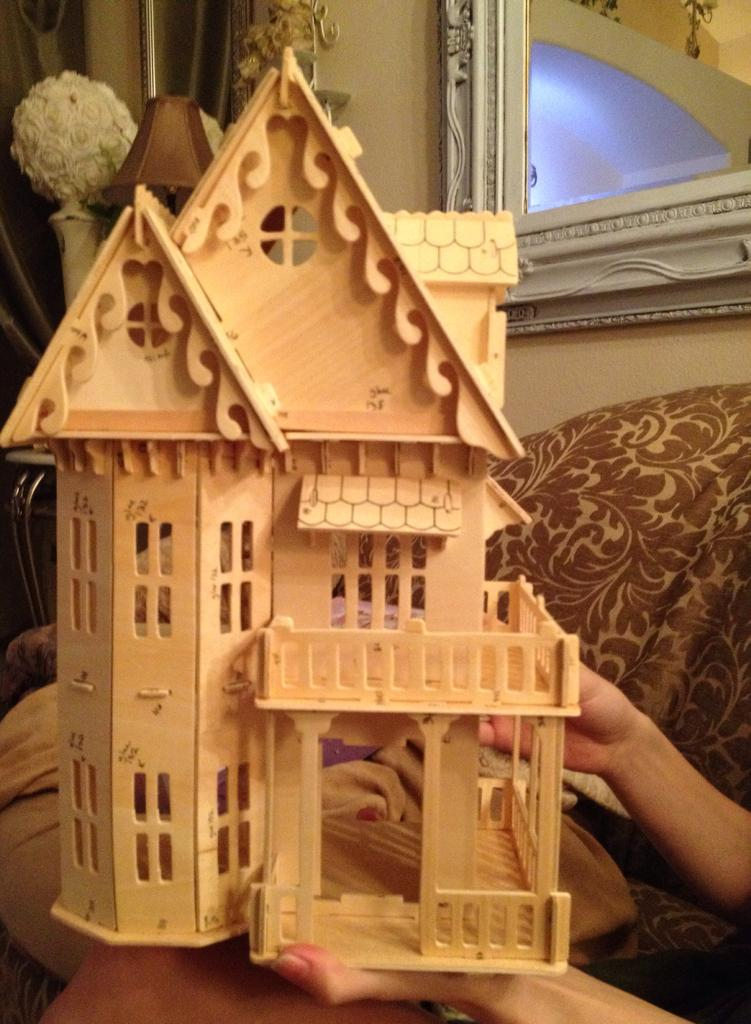What type of toy is present in the image? There is a toy house made of wood in the image. Whose hands are visible in the image? Human hands are visible in the image. What can be seen behind the toy house? There is a wall in the image. What is attached to the wall in the image? A frame is attached to the wall in the image. How does the beginner learn to play the guitar in the image? There is no guitar or indication of learning in the image; it features a wooden toy house, human hands, a wall, and a frame. 